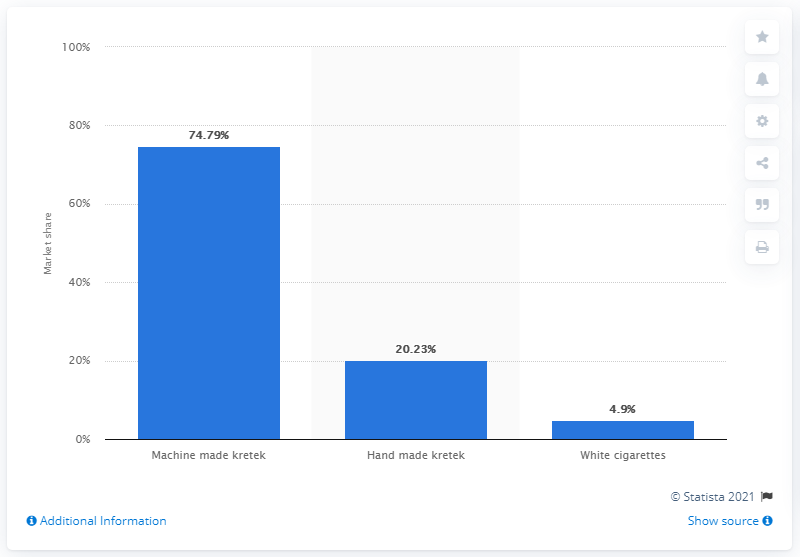Indicate a few pertinent items in this graphic. In 2017, the market share of machine-made kretek cigarettes in Indonesia was 74.79%. 